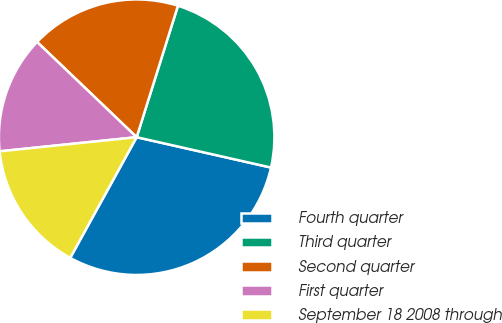<chart> <loc_0><loc_0><loc_500><loc_500><pie_chart><fcel>Fourth quarter<fcel>Third quarter<fcel>Second quarter<fcel>First quarter<fcel>September 18 2008 through<nl><fcel>29.47%<fcel>23.69%<fcel>17.7%<fcel>13.78%<fcel>15.35%<nl></chart> 